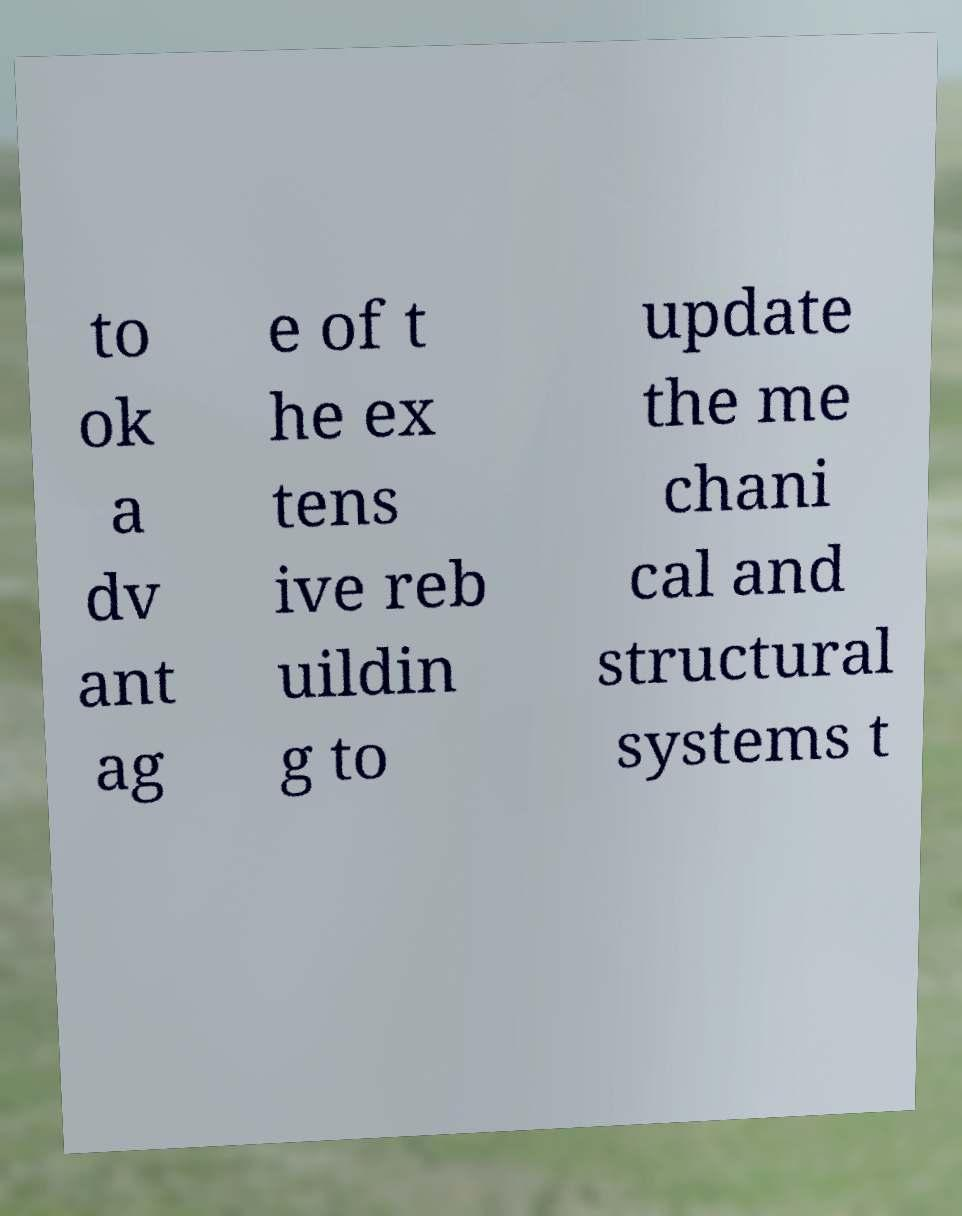Could you extract and type out the text from this image? to ok a dv ant ag e of t he ex tens ive reb uildin g to update the me chani cal and structural systems t 